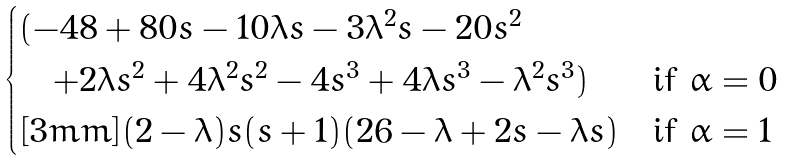Convert formula to latex. <formula><loc_0><loc_0><loc_500><loc_500>\begin{cases} ( - 4 8 + 8 0 s - 1 0 \lambda s - 3 \lambda ^ { 2 } s - 2 0 s ^ { 2 } & \\ \quad + 2 \lambda s ^ { 2 } + 4 \lambda ^ { 2 } s ^ { 2 } - 4 s ^ { 3 } + 4 \lambda s ^ { 3 } - \lambda ^ { 2 } s ^ { 3 } ) & \text {if $\alpha=0$} \\ [ 3 m m ] ( 2 - \lambda ) s ( s + 1 ) ( 2 6 - \lambda + 2 s - \lambda s ) & \text {if $\alpha=1$} \end{cases}</formula> 